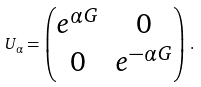<formula> <loc_0><loc_0><loc_500><loc_500>U _ { \alpha } = \begin{pmatrix} e ^ { \alpha G } & 0 \\ 0 & e ^ { - \alpha G } \\ \end{pmatrix} \, .</formula> 